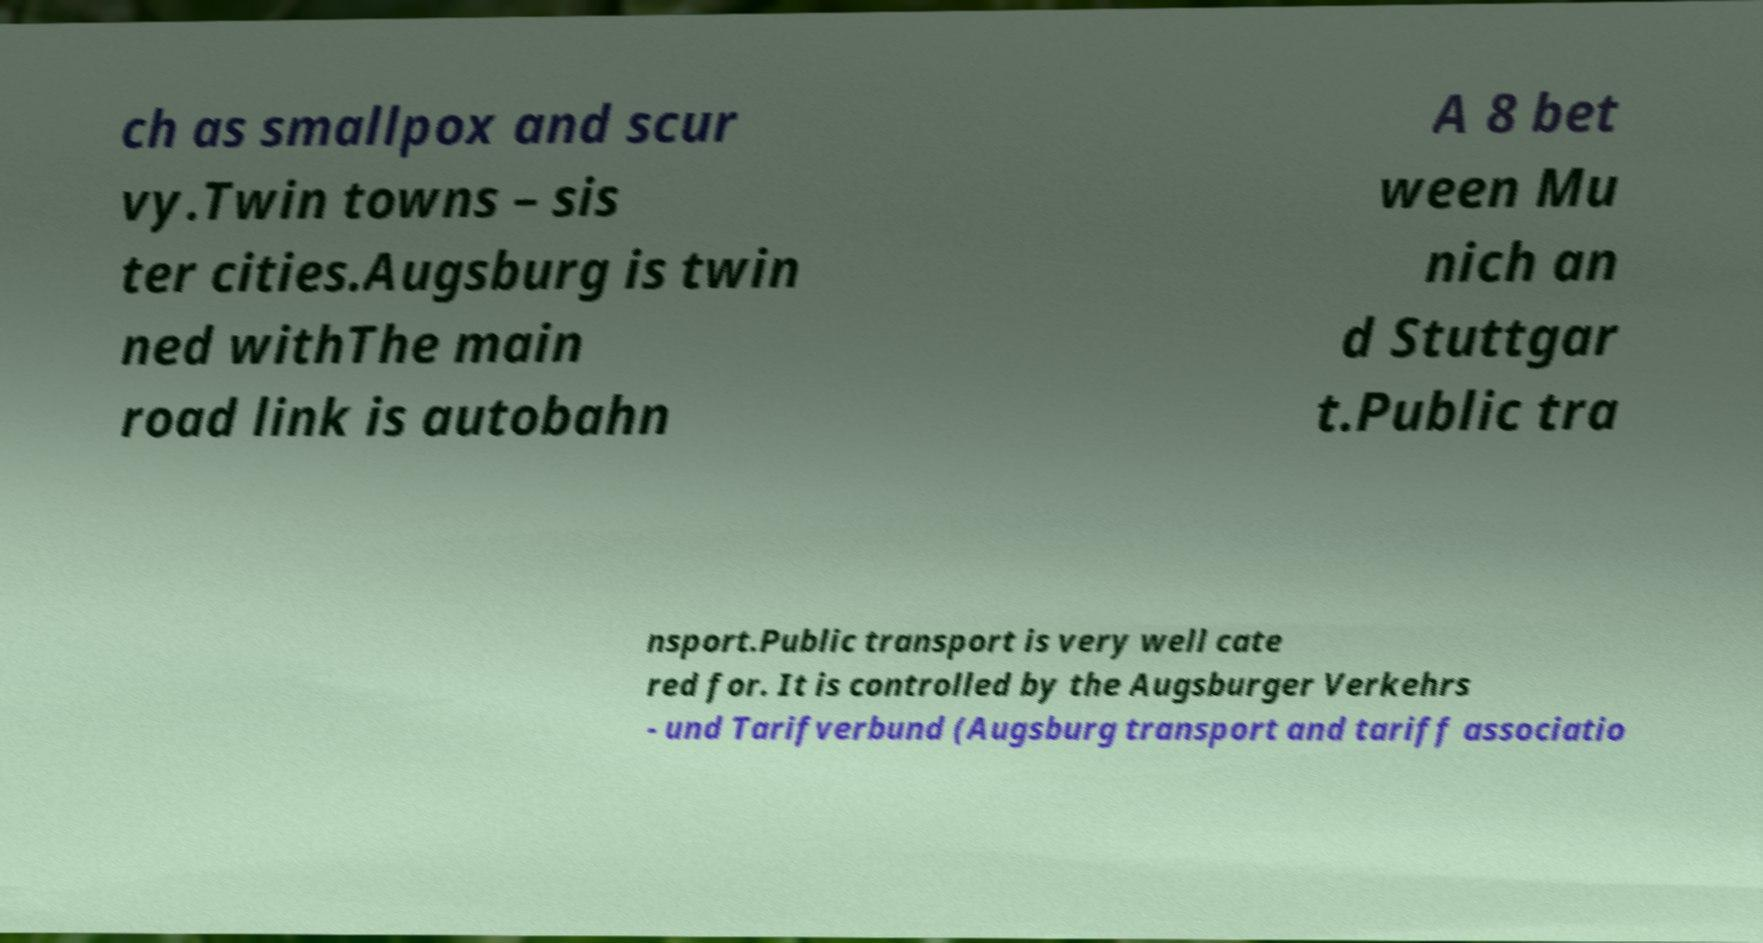There's text embedded in this image that I need extracted. Can you transcribe it verbatim? ch as smallpox and scur vy.Twin towns – sis ter cities.Augsburg is twin ned withThe main road link is autobahn A 8 bet ween Mu nich an d Stuttgar t.Public tra nsport.Public transport is very well cate red for. It is controlled by the Augsburger Verkehrs - und Tarifverbund (Augsburg transport and tariff associatio 